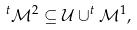<formula> <loc_0><loc_0><loc_500><loc_500>^ { t } \mathcal { M } ^ { 2 } \subseteq \mathcal { U } \cup ^ { t } \mathcal { M } ^ { 1 } ,</formula> 